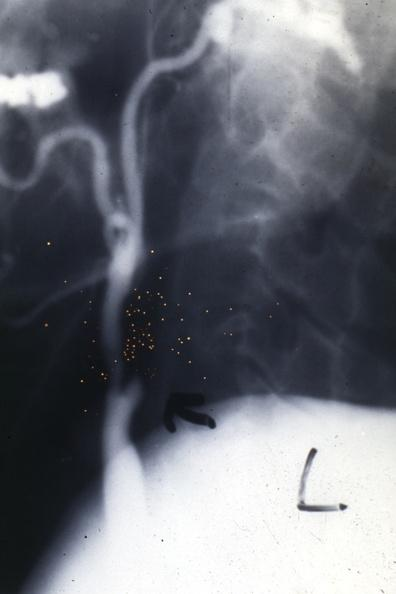s aorta present?
Answer the question using a single word or phrase. Yes 